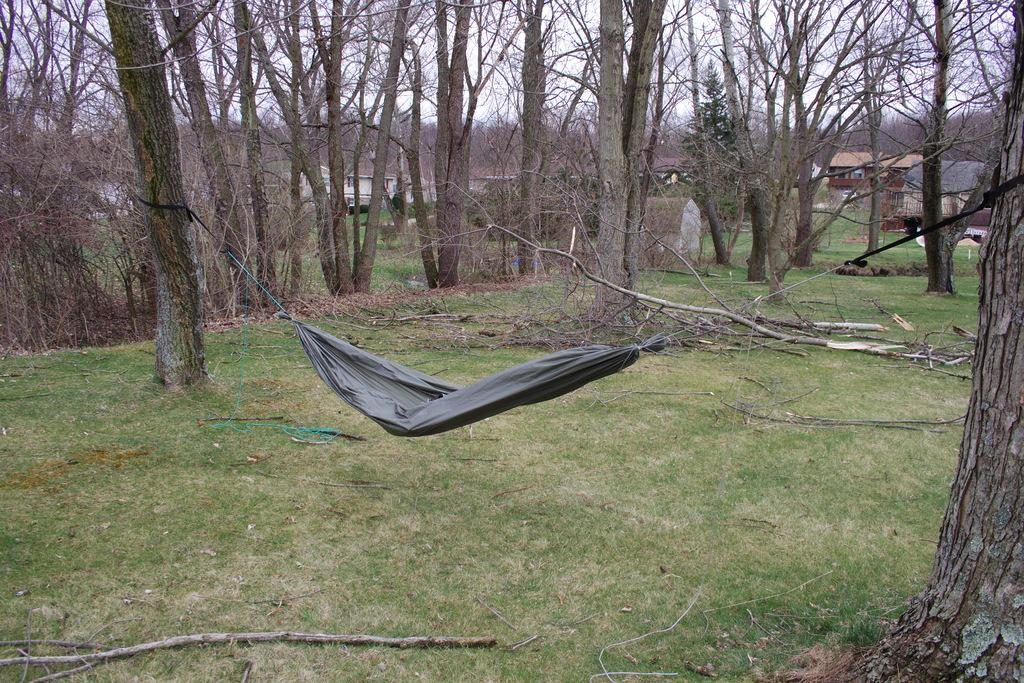What is tied between the trees in the image? There is a hammock tied between the trees in the image. What can be seen in the background of the image? There are trees and buildings in the background of the image. What type of ground is visible in the image? There is grass on the ground in the image. What else can be seen on the trees in the image? There are branches of trees visible in the image. What type of letter is being written on the hammock in the image? There is no letter being written on the hammock in the image; it is a hammock tied between trees. Is there any wound visible on the trees in the image? There is no wound visible on the trees in the image; only branches and leaves are visible. 